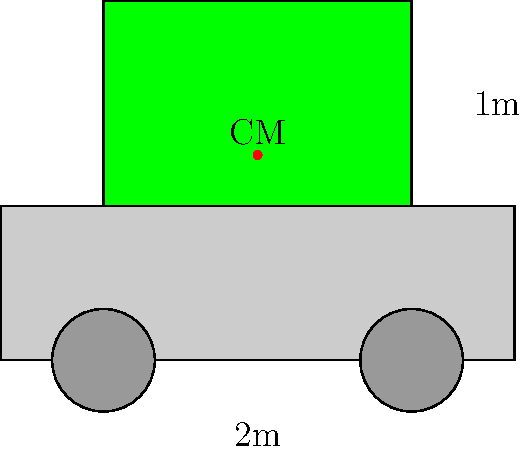A farmer uses a cart to transport harvested crops from the rainforest. The empty cart has a mass of 50 kg, and its center of mass is at the geometric center. The farmer loads 150 kg of crops, distributed evenly on top of the cart. If the cart is 2 meters long and the load is 1 meter high, how far above the bottom of the cart is the new center of mass of the loaded cart? Let's approach this step-by-step:

1) First, we need to understand that the center of mass of the combined system (cart + load) will be between the center of mass of the empty cart and the center of mass of the load.

2) Let's define our coordinate system:
   - The bottom of the cart is y = 0
   - The top of the cart is y = 0.3 m (assuming the cart is about 0.3 m high)
   - The top of the load is y = 1.3 m

3) The center of mass of the empty cart is at y = 0.15 m (half the height of the cart).

4) The center of mass of the load is at y = 0.8 m (0.3 m (top of cart) + 0.5 m (half the height of the load)).

5) We can use the formula for the center of mass of a system:

   $$y_{CM} = \frac{m_1y_1 + m_2y_2}{m_1 + m_2}$$

   Where:
   $m_1$ = mass of the cart = 50 kg
   $y_1$ = center of mass of the cart = 0.15 m
   $m_2$ = mass of the load = 150 kg
   $y_2$ = center of mass of the load = 0.8 m

6) Plugging in the values:

   $$y_{CM} = \frac{50(0.15) + 150(0.8)}{50 + 150}$$

7) Simplifying:

   $$y_{CM} = \frac{7.5 + 120}{200} = \frac{127.5}{200} = 0.6375 \text{ m}$$

Therefore, the new center of mass is 0.6375 meters above the bottom of the cart.
Answer: 0.6375 m 